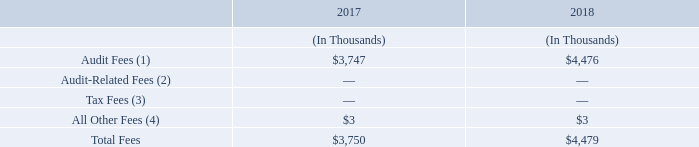Fees Paid to the Independent Registered Public Accounting Firm
The following table presents fees for professional audit services and other services rendered to our company by KPMG for our fiscal years ended December 31, 2017 and 2018.
(1) Audit Fees consist of professional services rendered in connection with the audit of our annual consolidated financial statements, including audited financial statements presented in our Annual Report on Form 10-K for the fiscal years ended December 31, 2017 and 2018 and services that are normally provided by the independent registered public accountants in connection with statutory and regulatory filings or engagements for those fiscal years.
(2) Audit-Related Fees consist of fees for professional services for assurance and related
services that are reasonably related to the performance of the audit or review of our consolidated financial statements and are not reported under “Audit Fees.” These services could include accounting consultations concerning financial accounting and reporting standards, due diligence procedures in connection with acquisition and procedures related to other attestation services.
(3) Tax Fees consist of fees for professional services for tax compliance, tax advice and tax planning. These services include consultation on tax matters and assistance regarding federal, state and international tax compliance.
(4) All Other Fees consist of license fees for the use of accounting research software.
What does “All Other Fees” consist of? License fees for the use of accounting research software. What does “Tax Fees” consist of? Fees for professional services for tax compliance, tax advice and tax planning. Which firm does the company hire for professional audit services and other services? Kpmg. What is the average total fees paid to KPMG from 2017 to 2018?
Answer scale should be: thousand. (3,750 + 4,479) / 2 
Answer: 4114.5. What is the percentage change of the Audit fees from 2017 to 2018?
Answer scale should be: percent. (4,476 - 3,747) / 3,747 
Answer: 19.46. What is the change of “All Other Fees” from 2017 to 2018?
Answer scale should be: thousand. 3 - 3 
Answer: 0. 